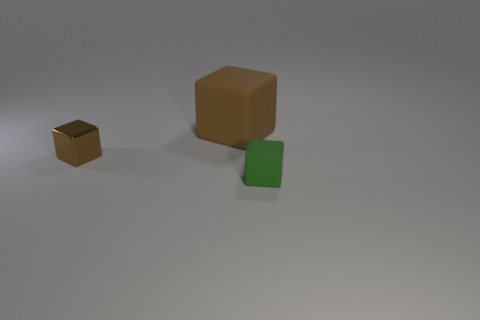Subtract all brown shiny cubes. How many cubes are left? 2 Add 2 big brown rubber objects. How many objects exist? 5 Subtract all green cubes. How many cubes are left? 2 Subtract 1 blocks. How many blocks are left? 2 Subtract all small rubber cubes. Subtract all big green metal blocks. How many objects are left? 2 Add 1 tiny metal objects. How many tiny metal objects are left? 2 Add 3 brown things. How many brown things exist? 5 Subtract 0 red spheres. How many objects are left? 3 Subtract all red blocks. Subtract all yellow spheres. How many blocks are left? 3 Subtract all red cylinders. How many brown cubes are left? 2 